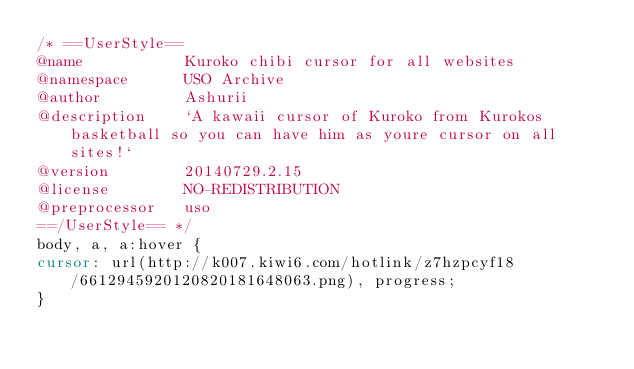<code> <loc_0><loc_0><loc_500><loc_500><_CSS_>/* ==UserStyle==
@name           Kuroko chibi cursor for all websites
@namespace      USO Archive
@author         Ashurii
@description    `A kawaii cursor of Kuroko from Kurokos basketball so you can have him as youre cursor on all sites!`
@version        20140729.2.15
@license        NO-REDISTRIBUTION
@preprocessor   uso
==/UserStyle== */
body, a, a:hover {
cursor: url(http://k007.kiwi6.com/hotlink/z7hzpcyf18/6612945920120820181648063.png), progress;
}</code> 